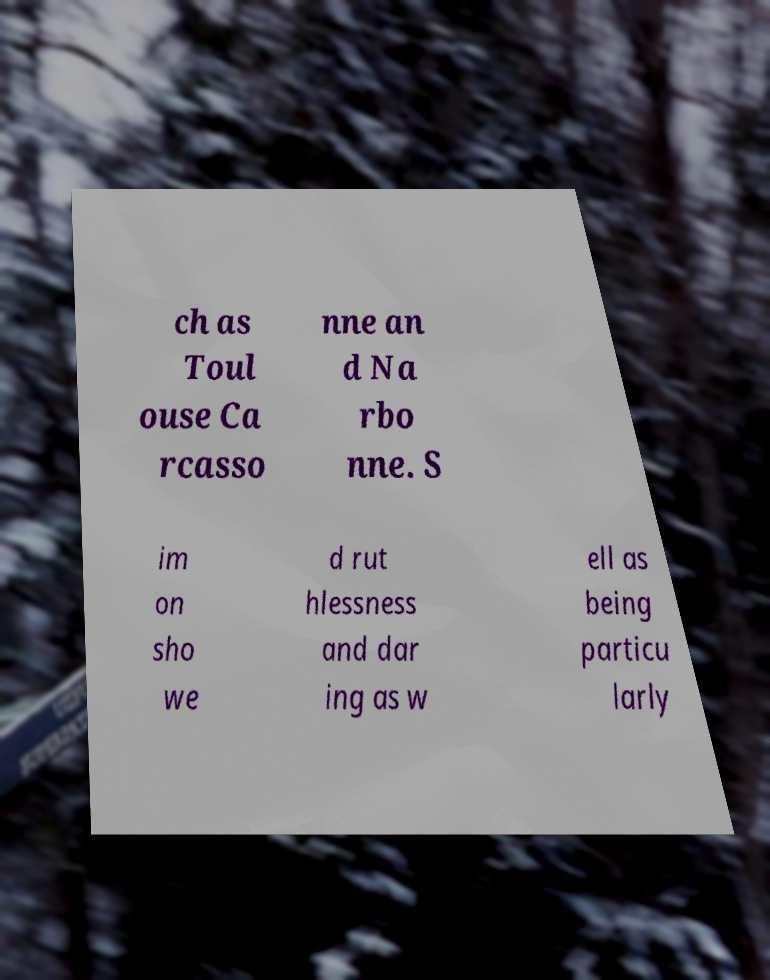Could you extract and type out the text from this image? ch as Toul ouse Ca rcasso nne an d Na rbo nne. S im on sho we d rut hlessness and dar ing as w ell as being particu larly 